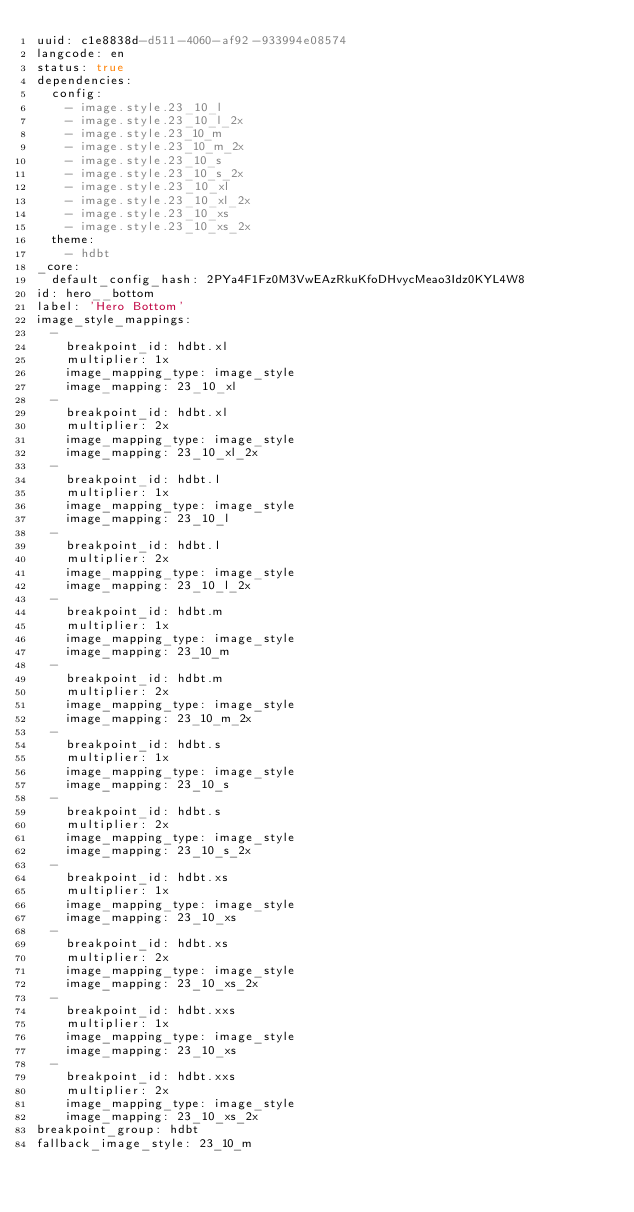Convert code to text. <code><loc_0><loc_0><loc_500><loc_500><_YAML_>uuid: c1e8838d-d511-4060-af92-933994e08574
langcode: en
status: true
dependencies:
  config:
    - image.style.23_10_l
    - image.style.23_10_l_2x
    - image.style.23_10_m
    - image.style.23_10_m_2x
    - image.style.23_10_s
    - image.style.23_10_s_2x
    - image.style.23_10_xl
    - image.style.23_10_xl_2x
    - image.style.23_10_xs
    - image.style.23_10_xs_2x
  theme:
    - hdbt
_core:
  default_config_hash: 2PYa4F1Fz0M3VwEAzRkuKfoDHvycMeao3Idz0KYL4W8
id: hero__bottom
label: 'Hero Bottom'
image_style_mappings:
  -
    breakpoint_id: hdbt.xl
    multiplier: 1x
    image_mapping_type: image_style
    image_mapping: 23_10_xl
  -
    breakpoint_id: hdbt.xl
    multiplier: 2x
    image_mapping_type: image_style
    image_mapping: 23_10_xl_2x
  -
    breakpoint_id: hdbt.l
    multiplier: 1x
    image_mapping_type: image_style
    image_mapping: 23_10_l
  -
    breakpoint_id: hdbt.l
    multiplier: 2x
    image_mapping_type: image_style
    image_mapping: 23_10_l_2x
  -
    breakpoint_id: hdbt.m
    multiplier: 1x
    image_mapping_type: image_style
    image_mapping: 23_10_m
  -
    breakpoint_id: hdbt.m
    multiplier: 2x
    image_mapping_type: image_style
    image_mapping: 23_10_m_2x
  -
    breakpoint_id: hdbt.s
    multiplier: 1x
    image_mapping_type: image_style
    image_mapping: 23_10_s
  -
    breakpoint_id: hdbt.s
    multiplier: 2x
    image_mapping_type: image_style
    image_mapping: 23_10_s_2x
  -
    breakpoint_id: hdbt.xs
    multiplier: 1x
    image_mapping_type: image_style
    image_mapping: 23_10_xs
  -
    breakpoint_id: hdbt.xs
    multiplier: 2x
    image_mapping_type: image_style
    image_mapping: 23_10_xs_2x
  -
    breakpoint_id: hdbt.xxs
    multiplier: 1x
    image_mapping_type: image_style
    image_mapping: 23_10_xs
  -
    breakpoint_id: hdbt.xxs
    multiplier: 2x
    image_mapping_type: image_style
    image_mapping: 23_10_xs_2x
breakpoint_group: hdbt
fallback_image_style: 23_10_m
</code> 